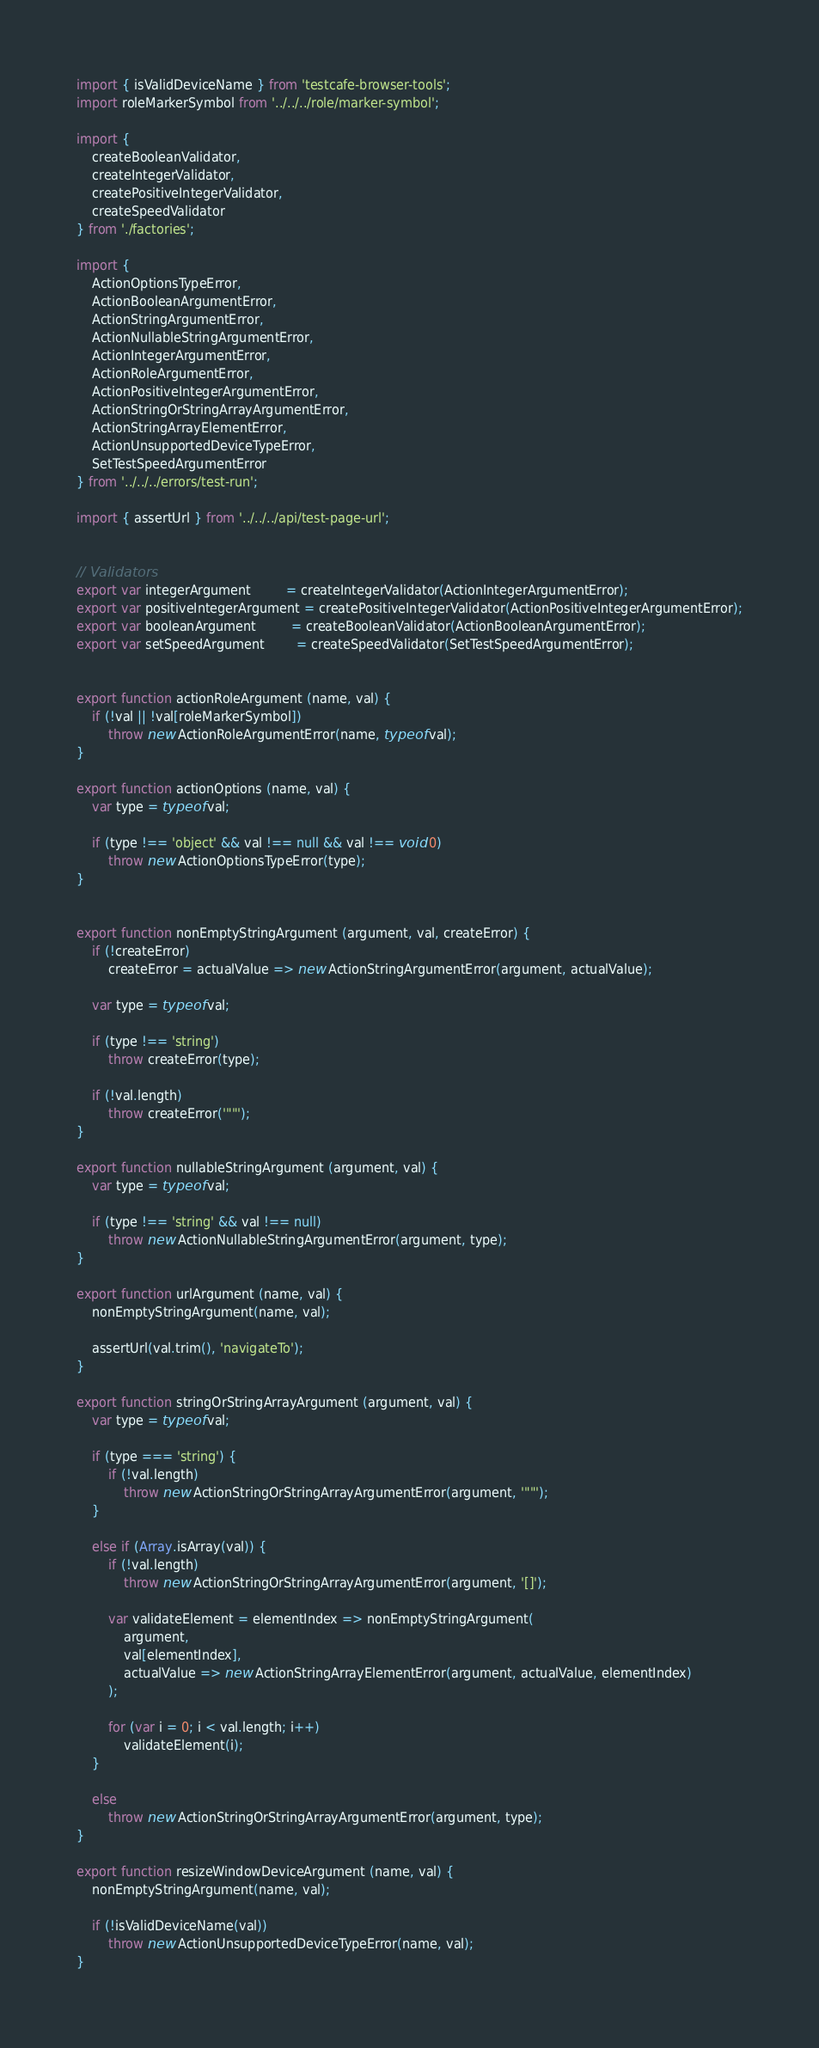Convert code to text. <code><loc_0><loc_0><loc_500><loc_500><_JavaScript_>import { isValidDeviceName } from 'testcafe-browser-tools';
import roleMarkerSymbol from '../../../role/marker-symbol';

import {
    createBooleanValidator,
    createIntegerValidator,
    createPositiveIntegerValidator,
    createSpeedValidator
} from './factories';

import {
    ActionOptionsTypeError,
    ActionBooleanArgumentError,
    ActionStringArgumentError,
    ActionNullableStringArgumentError,
    ActionIntegerArgumentError,
    ActionRoleArgumentError,
    ActionPositiveIntegerArgumentError,
    ActionStringOrStringArrayArgumentError,
    ActionStringArrayElementError,
    ActionUnsupportedDeviceTypeError,
    SetTestSpeedArgumentError
} from '../../../errors/test-run';

import { assertUrl } from '../../../api/test-page-url';


// Validators
export var integerArgument         = createIntegerValidator(ActionIntegerArgumentError);
export var positiveIntegerArgument = createPositiveIntegerValidator(ActionPositiveIntegerArgumentError);
export var booleanArgument         = createBooleanValidator(ActionBooleanArgumentError);
export var setSpeedArgument        = createSpeedValidator(SetTestSpeedArgumentError);


export function actionRoleArgument (name, val) {
    if (!val || !val[roleMarkerSymbol])
        throw new ActionRoleArgumentError(name, typeof val);
}

export function actionOptions (name, val) {
    var type = typeof val;

    if (type !== 'object' && val !== null && val !== void 0)
        throw new ActionOptionsTypeError(type);
}


export function nonEmptyStringArgument (argument, val, createError) {
    if (!createError)
        createError = actualValue => new ActionStringArgumentError(argument, actualValue);

    var type = typeof val;

    if (type !== 'string')
        throw createError(type);

    if (!val.length)
        throw createError('""');
}

export function nullableStringArgument (argument, val) {
    var type = typeof val;

    if (type !== 'string' && val !== null)
        throw new ActionNullableStringArgumentError(argument, type);
}

export function urlArgument (name, val) {
    nonEmptyStringArgument(name, val);

    assertUrl(val.trim(), 'navigateTo');
}

export function stringOrStringArrayArgument (argument, val) {
    var type = typeof val;

    if (type === 'string') {
        if (!val.length)
            throw new ActionStringOrStringArrayArgumentError(argument, '""');
    }

    else if (Array.isArray(val)) {
        if (!val.length)
            throw new ActionStringOrStringArrayArgumentError(argument, '[]');

        var validateElement = elementIndex => nonEmptyStringArgument(
            argument,
            val[elementIndex],
            actualValue => new ActionStringArrayElementError(argument, actualValue, elementIndex)
        );

        for (var i = 0; i < val.length; i++)
            validateElement(i);
    }

    else
        throw new ActionStringOrStringArrayArgumentError(argument, type);
}

export function resizeWindowDeviceArgument (name, val) {
    nonEmptyStringArgument(name, val);

    if (!isValidDeviceName(val))
        throw new ActionUnsupportedDeviceTypeError(name, val);
}
</code> 